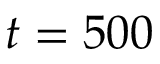<formula> <loc_0><loc_0><loc_500><loc_500>t = 5 0 0</formula> 